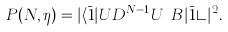Convert formula to latex. <formula><loc_0><loc_0><loc_500><loc_500>P ( N , \eta ) = | \langle \bar { 1 } | U D ^ { N - 1 } U ^ { \dagger } B | \bar { 1 } \rangle | ^ { 2 } .</formula> 